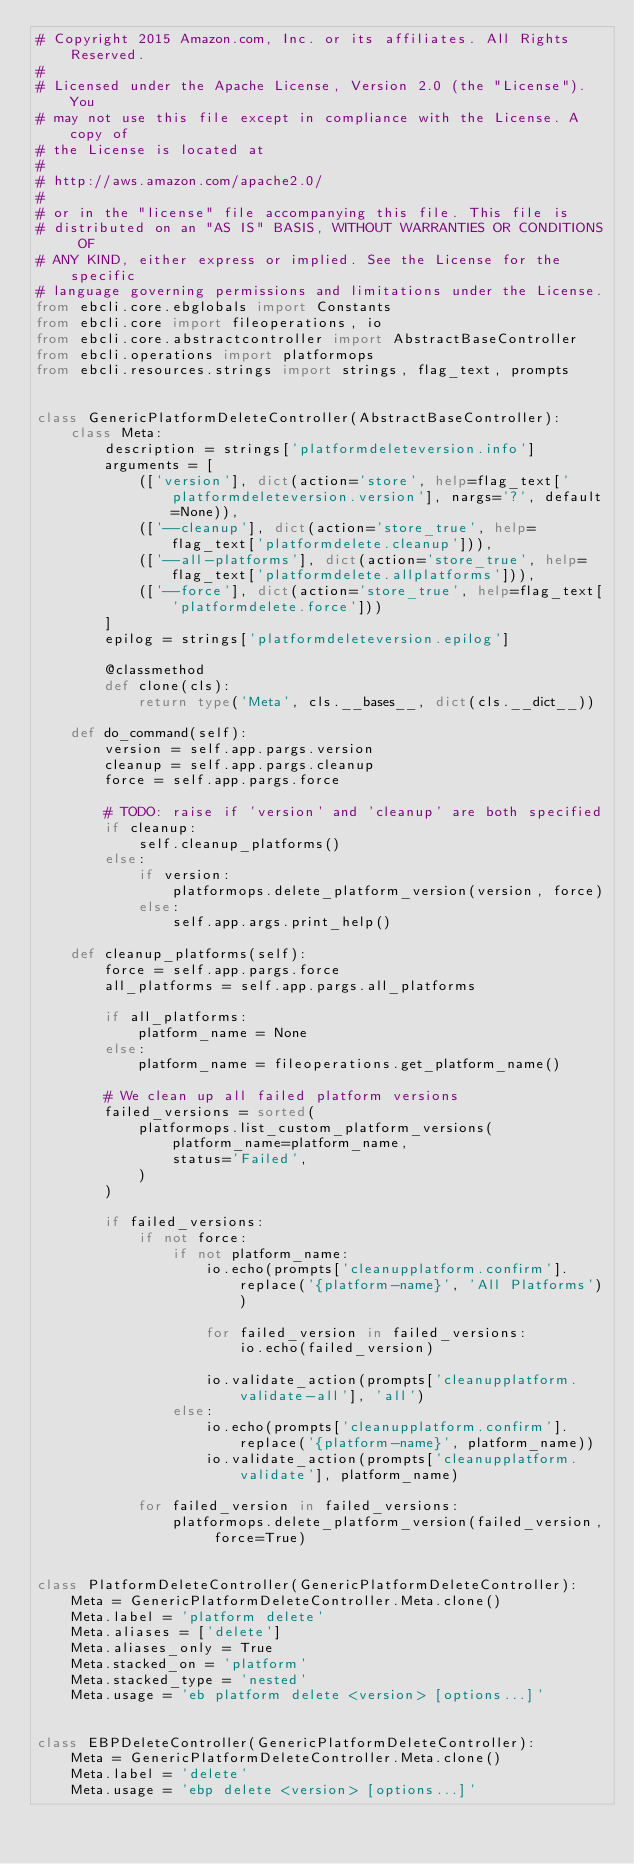Convert code to text. <code><loc_0><loc_0><loc_500><loc_500><_Python_># Copyright 2015 Amazon.com, Inc. or its affiliates. All Rights Reserved.
#
# Licensed under the Apache License, Version 2.0 (the "License"). You
# may not use this file except in compliance with the License. A copy of
# the License is located at
#
# http://aws.amazon.com/apache2.0/
#
# or in the "license" file accompanying this file. This file is
# distributed on an "AS IS" BASIS, WITHOUT WARRANTIES OR CONDITIONS OF
# ANY KIND, either express or implied. See the License for the specific
# language governing permissions and limitations under the License.
from ebcli.core.ebglobals import Constants
from ebcli.core import fileoperations, io
from ebcli.core.abstractcontroller import AbstractBaseController
from ebcli.operations import platformops
from ebcli.resources.strings import strings, flag_text, prompts


class GenericPlatformDeleteController(AbstractBaseController):
    class Meta:
        description = strings['platformdeleteversion.info']
        arguments = [
            (['version'], dict(action='store', help=flag_text['platformdeleteversion.version'], nargs='?', default=None)),
            (['--cleanup'], dict(action='store_true', help=flag_text['platformdelete.cleanup'])),
            (['--all-platforms'], dict(action='store_true', help=flag_text['platformdelete.allplatforms'])),
            (['--force'], dict(action='store_true', help=flag_text['platformdelete.force']))
        ]
        epilog = strings['platformdeleteversion.epilog']

        @classmethod
        def clone(cls):
            return type('Meta', cls.__bases__, dict(cls.__dict__))

    def do_command(self):
        version = self.app.pargs.version
        cleanup = self.app.pargs.cleanup
        force = self.app.pargs.force

        # TODO: raise if 'version' and 'cleanup' are both specified
        if cleanup:
            self.cleanup_platforms()
        else:
            if version:
                platformops.delete_platform_version(version, force)
            else:
                self.app.args.print_help()

    def cleanup_platforms(self):
        force = self.app.pargs.force
        all_platforms = self.app.pargs.all_platforms

        if all_platforms:
            platform_name = None
        else:
            platform_name = fileoperations.get_platform_name()

        # We clean up all failed platform versions
        failed_versions = sorted(
            platformops.list_custom_platform_versions(
                platform_name=platform_name,
                status='Failed',
            )
        )

        if failed_versions:
            if not force:
                if not platform_name:
                    io.echo(prompts['cleanupplatform.confirm'].replace('{platform-name}', 'All Platforms'))

                    for failed_version in failed_versions:
                        io.echo(failed_version)

                    io.validate_action(prompts['cleanupplatform.validate-all'], 'all')
                else:
                    io.echo(prompts['cleanupplatform.confirm'].replace('{platform-name}', platform_name))
                    io.validate_action(prompts['cleanupplatform.validate'], platform_name)

            for failed_version in failed_versions:
                platformops.delete_platform_version(failed_version, force=True)


class PlatformDeleteController(GenericPlatformDeleteController):
    Meta = GenericPlatformDeleteController.Meta.clone()
    Meta.label = 'platform delete'
    Meta.aliases = ['delete']
    Meta.aliases_only = True
    Meta.stacked_on = 'platform'
    Meta.stacked_type = 'nested'
    Meta.usage = 'eb platform delete <version> [options...]'


class EBPDeleteController(GenericPlatformDeleteController):
    Meta = GenericPlatformDeleteController.Meta.clone()
    Meta.label = 'delete'
    Meta.usage = 'ebp delete <version> [options...]'
</code> 